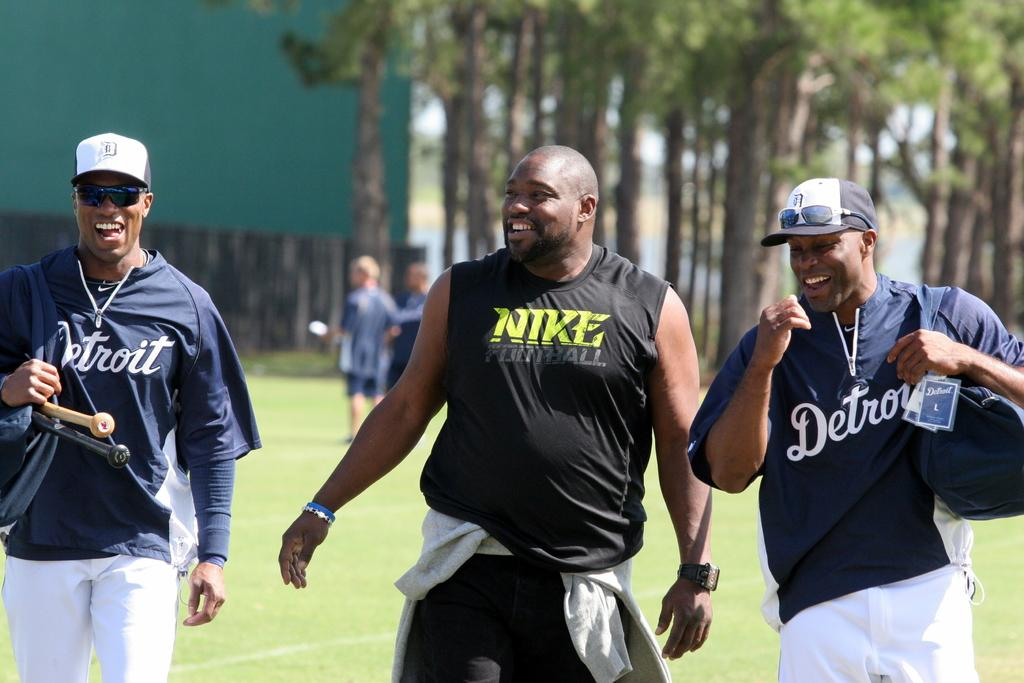<image>
Offer a succinct explanation of the picture presented. men in a park wearing shirts with Nike Football and Detroit on them 